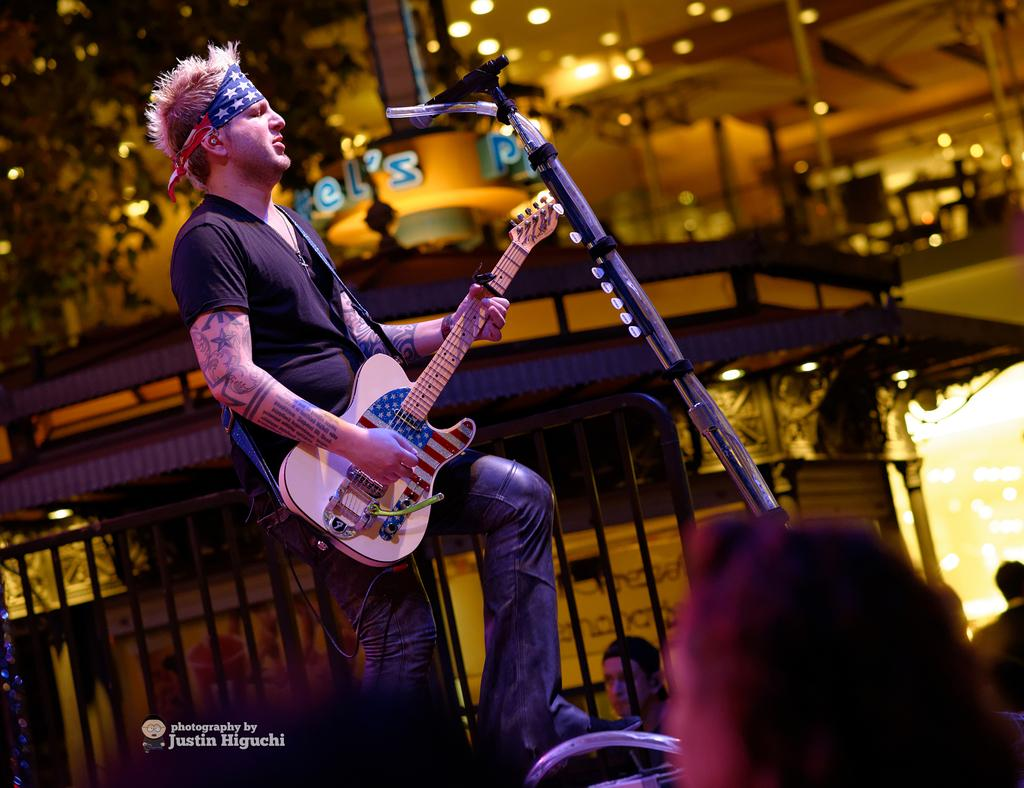What is the person in the image doing? The person is playing guitar in the image. What is the person playing guitar standing near? The person is in front of a microphone. Who is present in the image besides the person playing guitar? There are people in the audience in the image. What can be seen in the distance in the image? There is a building and a tree in the distance. What type of sand can be seen on the stage in the image? There is no sand present on the stage in the image. Can you tell me how many zebras are in the audience? There are no zebras present in the audience in the image. 